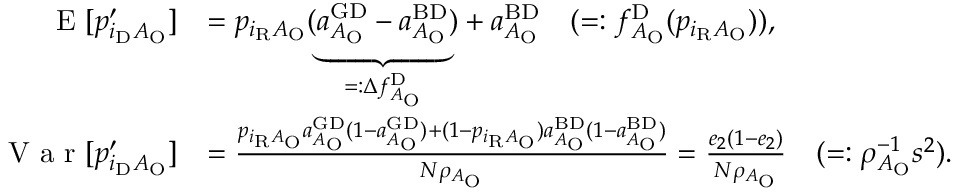<formula> <loc_0><loc_0><loc_500><loc_500>\begin{array} { r l } { E [ p _ { i _ { D } A _ { O } } ^ { \prime } ] } & { = p _ { i _ { R } A _ { O } } ( \underbrace { a _ { A _ { O } } ^ { G D } - a _ { A _ { O } } ^ { B D } } _ { = \colon \Delta f _ { A _ { O } } ^ { D } } ) + a _ { A _ { O } } ^ { B D } \quad ( = \colon f _ { A _ { O } } ^ { D } ( p _ { i _ { R } A _ { O } } ) ) , } \\ { V a r [ p _ { i _ { D } A _ { O } } ^ { \prime } ] } & { = \frac { p _ { i _ { R } A _ { O } } a _ { A _ { O } } ^ { G D } ( 1 - a _ { A _ { O } } ^ { G D } ) + ( 1 - p _ { i _ { R } A _ { O } } ) a _ { A _ { O } } ^ { B D } ( 1 - a _ { A _ { O } } ^ { B D } ) } { N \rho _ { A _ { O } } } = \frac { e _ { 2 } ( 1 - e _ { 2 } ) } { N \rho _ { A _ { O } } } \quad ( = \colon \rho _ { A _ { O } } ^ { - 1 } s ^ { 2 } ) . } \end{array}</formula> 